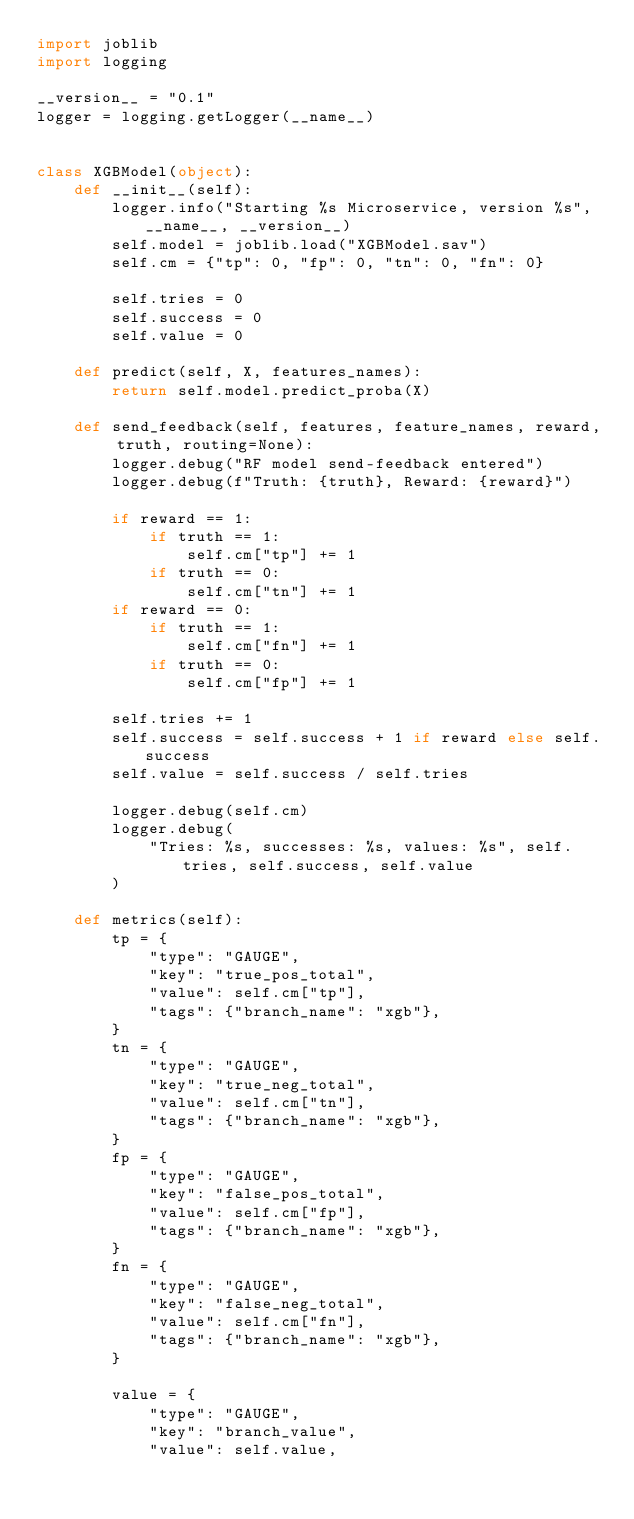Convert code to text. <code><loc_0><loc_0><loc_500><loc_500><_Python_>import joblib
import logging

__version__ = "0.1"
logger = logging.getLogger(__name__)


class XGBModel(object):
    def __init__(self):
        logger.info("Starting %s Microservice, version %s", __name__, __version__)
        self.model = joblib.load("XGBModel.sav")
        self.cm = {"tp": 0, "fp": 0, "tn": 0, "fn": 0}

        self.tries = 0
        self.success = 0
        self.value = 0

    def predict(self, X, features_names):
        return self.model.predict_proba(X)

    def send_feedback(self, features, feature_names, reward, truth, routing=None):
        logger.debug("RF model send-feedback entered")
        logger.debug(f"Truth: {truth}, Reward: {reward}")

        if reward == 1:
            if truth == 1:
                self.cm["tp"] += 1
            if truth == 0:
                self.cm["tn"] += 1
        if reward == 0:
            if truth == 1:
                self.cm["fn"] += 1
            if truth == 0:
                self.cm["fp"] += 1

        self.tries += 1
        self.success = self.success + 1 if reward else self.success
        self.value = self.success / self.tries

        logger.debug(self.cm)
        logger.debug(
            "Tries: %s, successes: %s, values: %s", self.tries, self.success, self.value
        )

    def metrics(self):
        tp = {
            "type": "GAUGE",
            "key": "true_pos_total",
            "value": self.cm["tp"],
            "tags": {"branch_name": "xgb"},
        }
        tn = {
            "type": "GAUGE",
            "key": "true_neg_total",
            "value": self.cm["tn"],
            "tags": {"branch_name": "xgb"},
        }
        fp = {
            "type": "GAUGE",
            "key": "false_pos_total",
            "value": self.cm["fp"],
            "tags": {"branch_name": "xgb"},
        }
        fn = {
            "type": "GAUGE",
            "key": "false_neg_total",
            "value": self.cm["fn"],
            "tags": {"branch_name": "xgb"},
        }

        value = {
            "type": "GAUGE",
            "key": "branch_value",
            "value": self.value,</code> 